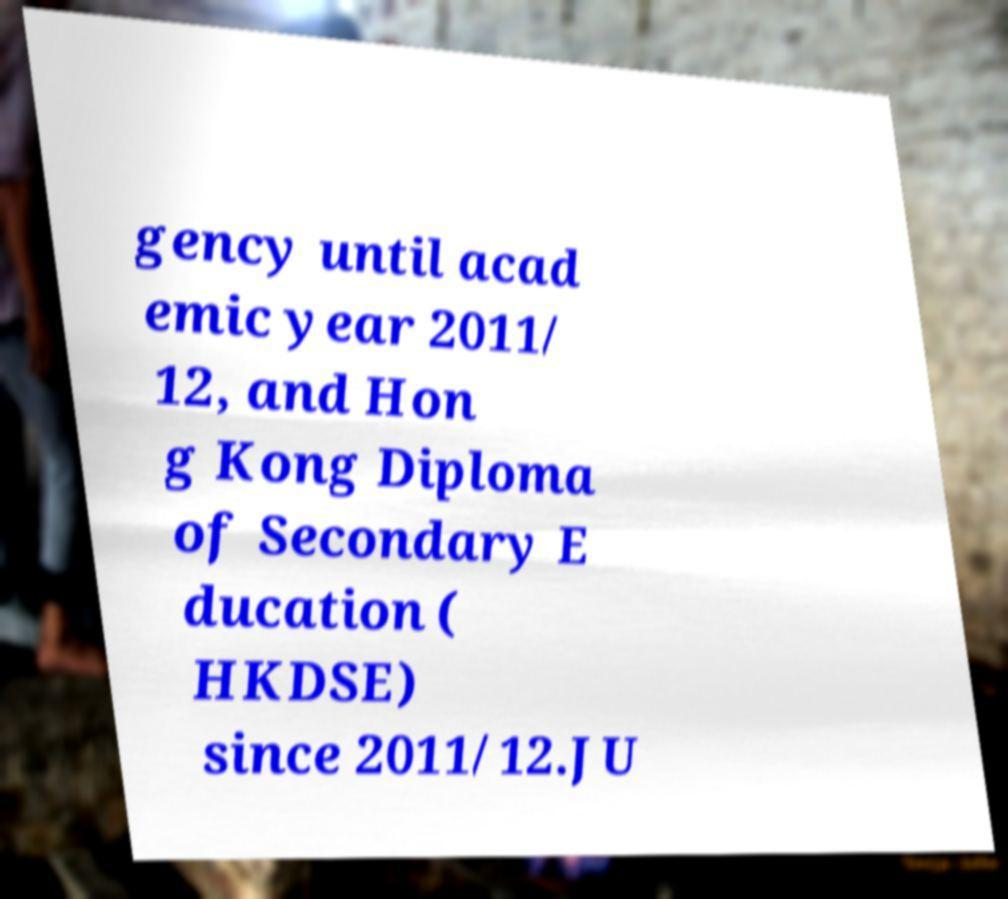For documentation purposes, I need the text within this image transcribed. Could you provide that? gency until acad emic year 2011/ 12, and Hon g Kong Diploma of Secondary E ducation ( HKDSE) since 2011/12.JU 